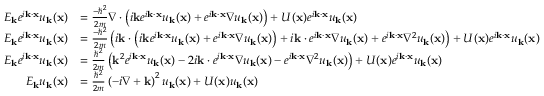Convert formula to latex. <formula><loc_0><loc_0><loc_500><loc_500>{ \begin{array} { r l } { E _ { k } e ^ { i k \cdot x } u _ { k } ( x ) } & { = { \frac { - \hbar { ^ } { 2 } } { 2 m } } \nabla \cdot \left ( i k e ^ { i k \cdot x } u _ { k } ( x ) + e ^ { i k \cdot x } \nabla u _ { k } ( x ) \right ) + U ( x ) e ^ { i k \cdot x } u _ { k } ( x ) } \\ { E _ { k } e ^ { i k \cdot x } u _ { k } ( x ) } & { = { \frac { - \hbar { ^ } { 2 } } { 2 m } } \left ( i k \cdot \left ( i k e ^ { i k \cdot x } u _ { k } ( x ) + e ^ { i k \cdot x } \nabla u _ { k } ( x ) \right ) + i k \cdot e ^ { i k \cdot x } \nabla u _ { k } ( x ) + e ^ { i k \cdot x } \nabla ^ { 2 } u _ { k } ( x ) \right ) + U ( x ) e ^ { i k \cdot x } u _ { k } ( x ) } \\ { E _ { k } e ^ { i k \cdot x } u _ { k } ( x ) } & { = { \frac { \hbar { ^ } { 2 } } { 2 m } } \left ( k ^ { 2 } e ^ { i k \cdot x } u _ { k } ( x ) - 2 i k \cdot e ^ { i k \cdot x } \nabla u _ { k } ( x ) - e ^ { i k \cdot x } \nabla ^ { 2 } u _ { k } ( x ) \right ) + U ( x ) e ^ { i k \cdot x } u _ { k } ( x ) } \\ { E _ { k } u _ { k } ( x ) } & { = { \frac { \hbar { ^ } { 2 } } { 2 m } } \left ( - i \nabla + k \right ) ^ { 2 } u _ { k } ( x ) + U ( x ) u _ { k } ( x ) } \end{array} }</formula> 